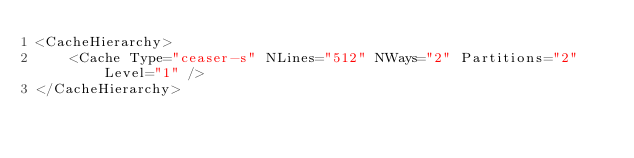Convert code to text. <code><loc_0><loc_0><loc_500><loc_500><_XML_><CacheHierarchy>
	<Cache Type="ceaser-s" NLines="512" NWays="2" Partitions="2" Level="1" />
</CacheHierarchy>
</code> 